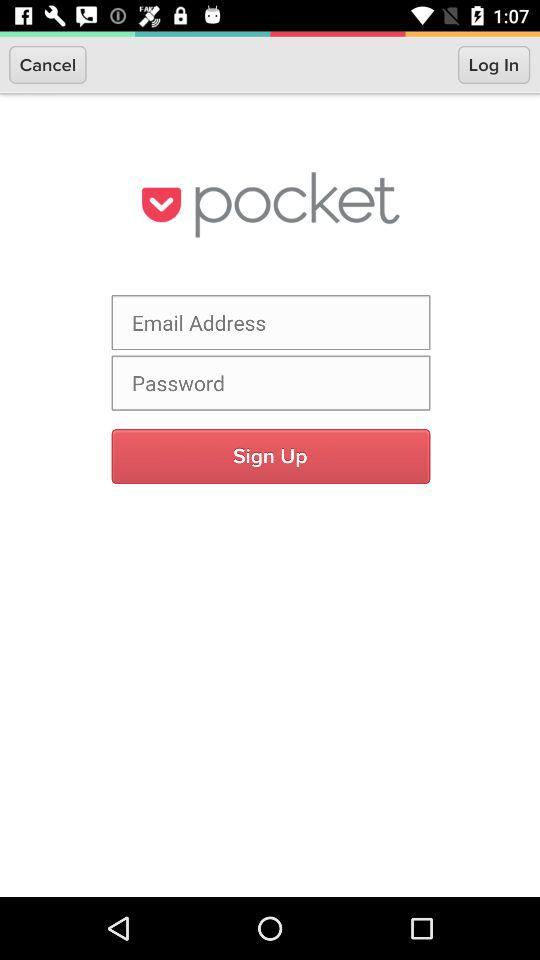What is the name of the application? The name of the application is "pocket". 